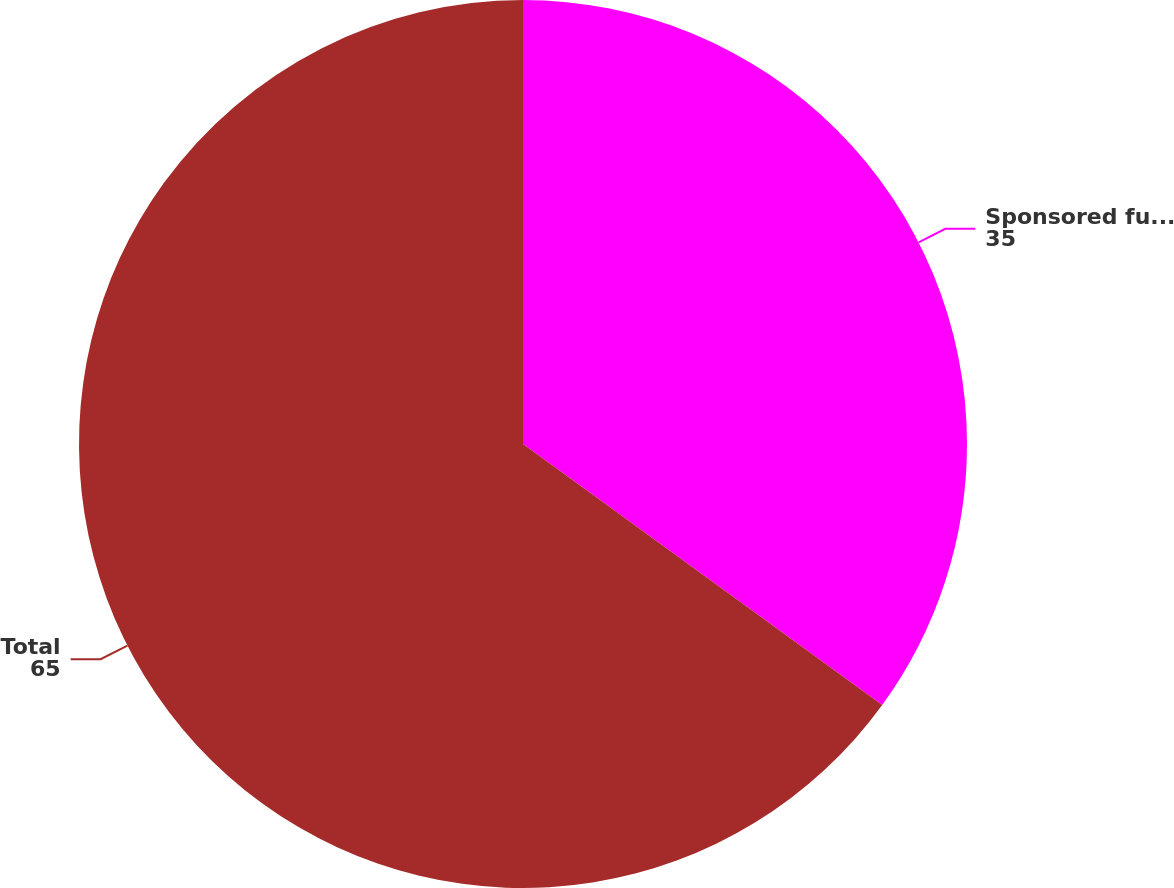Convert chart to OTSL. <chart><loc_0><loc_0><loc_500><loc_500><pie_chart><fcel>Sponsored funds<fcel>Total<nl><fcel>35.0%<fcel>65.0%<nl></chart> 